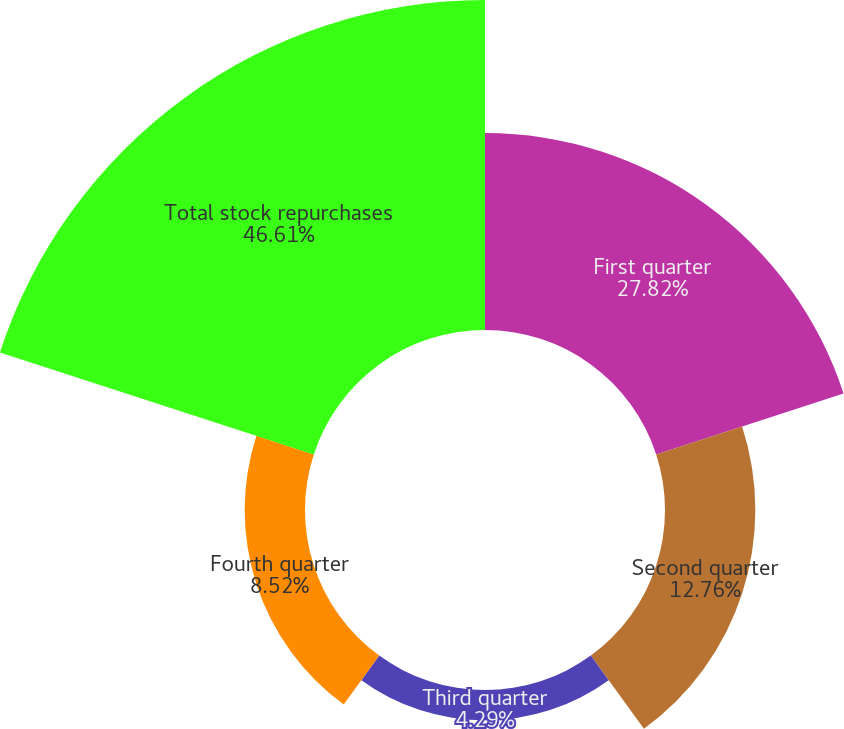Convert chart. <chart><loc_0><loc_0><loc_500><loc_500><pie_chart><fcel>First quarter<fcel>Second quarter<fcel>Third quarter<fcel>Fourth quarter<fcel>Total stock repurchases<nl><fcel>27.82%<fcel>12.76%<fcel>4.29%<fcel>8.52%<fcel>46.61%<nl></chart> 